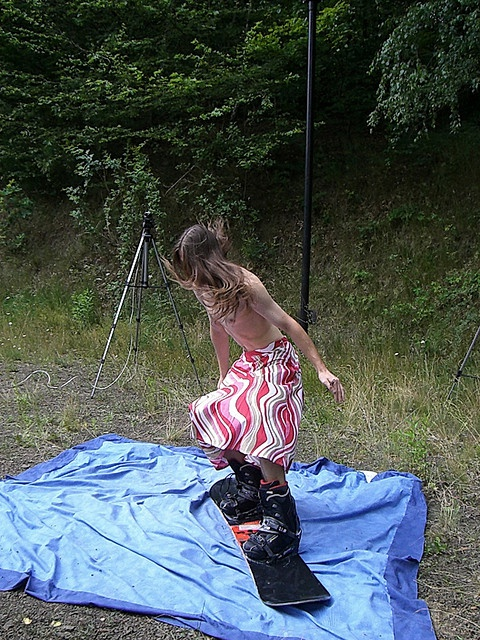Describe the objects in this image and their specific colors. I can see people in darkgreen, black, gray, and lavender tones and snowboard in darkgreen, black, lavender, and gray tones in this image. 